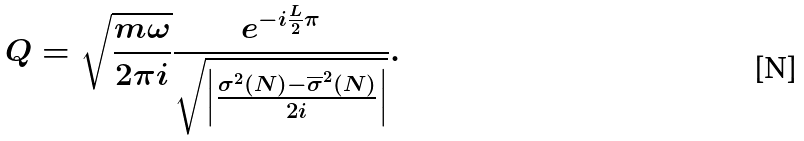<formula> <loc_0><loc_0><loc_500><loc_500>Q = \sqrt { \frac { m \omega } { 2 \pi i } } \frac { e ^ { - i \frac { L } { 2 } \pi } } { \sqrt { \left | \frac { \sigma ^ { 2 } ( N ) - { \overline { \sigma } } ^ { 2 } ( N ) } { 2 i } \right | } } .</formula> 